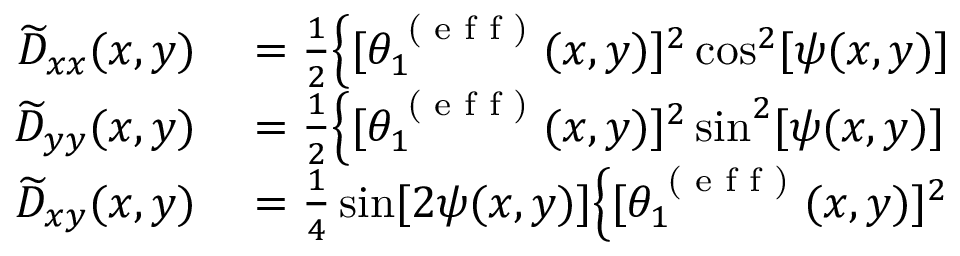<formula> <loc_0><loc_0><loc_500><loc_500>\begin{array} { r l } { \widetilde { D } _ { x x } ( x , y ) } & = \frac { 1 } { 2 } \Big \{ [ \theta _ { 1 } ^ { ( e f f ) } ( x , y ) ] ^ { 2 } \cos ^ { 2 } [ \psi ( x , y ) ] } \\ { \widetilde { D } _ { y y } ( x , y ) } & = \frac { 1 } { 2 } \Big \{ [ \theta _ { 1 } ^ { ( e f f ) } ( x , y ) ] ^ { 2 } \sin ^ { 2 } [ \psi ( x , y ) ] } \\ { \widetilde { D } _ { x y } ( x , y ) } & = \frac { 1 } { 4 } \sin [ 2 \psi ( x , y ) ] \Big \{ [ \theta _ { 1 } ^ { ( e f f ) } ( x , y ) ] ^ { 2 } } \end{array}</formula> 